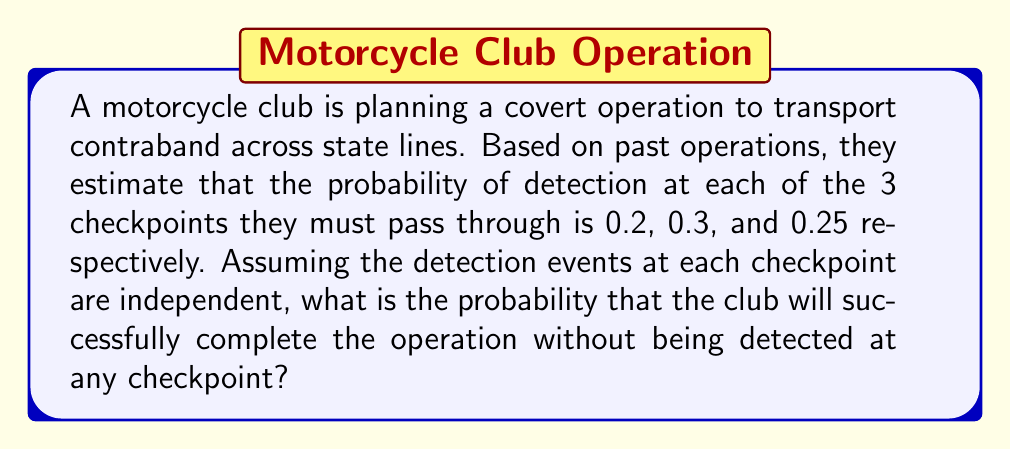What is the answer to this math problem? To solve this problem, we need to use the concept of independent events and the complement of probability.

Let's define the events:
$A$: Successfully passing checkpoint 1
$B$: Successfully passing checkpoint 2
$C$: Successfully passing checkpoint 3

Given:
$P(\text{detection at checkpoint 1}) = 0.2$
$P(\text{detection at checkpoint 2}) = 0.3$
$P(\text{detection at checkpoint 3}) = 0.25$

Step 1: Calculate the probability of success at each checkpoint
$P(A) = 1 - 0.2 = 0.8$
$P(B) = 1 - 0.3 = 0.7$
$P(C) = 1 - 0.25 = 0.75$

Step 2: Since the events are independent, we can multiply the probabilities of success at each checkpoint to get the overall probability of success.

$$P(\text{success}) = P(A \cap B \cap C) = P(A) \cdot P(B) \cdot P(C)$$

Step 3: Substitute the values and calculate

$$P(\text{success}) = 0.8 \cdot 0.7 \cdot 0.75 = 0.42$$

Therefore, the probability of successfully completing the operation without being detected is 0.42 or 42%.
Answer: 0.42 or 42% 